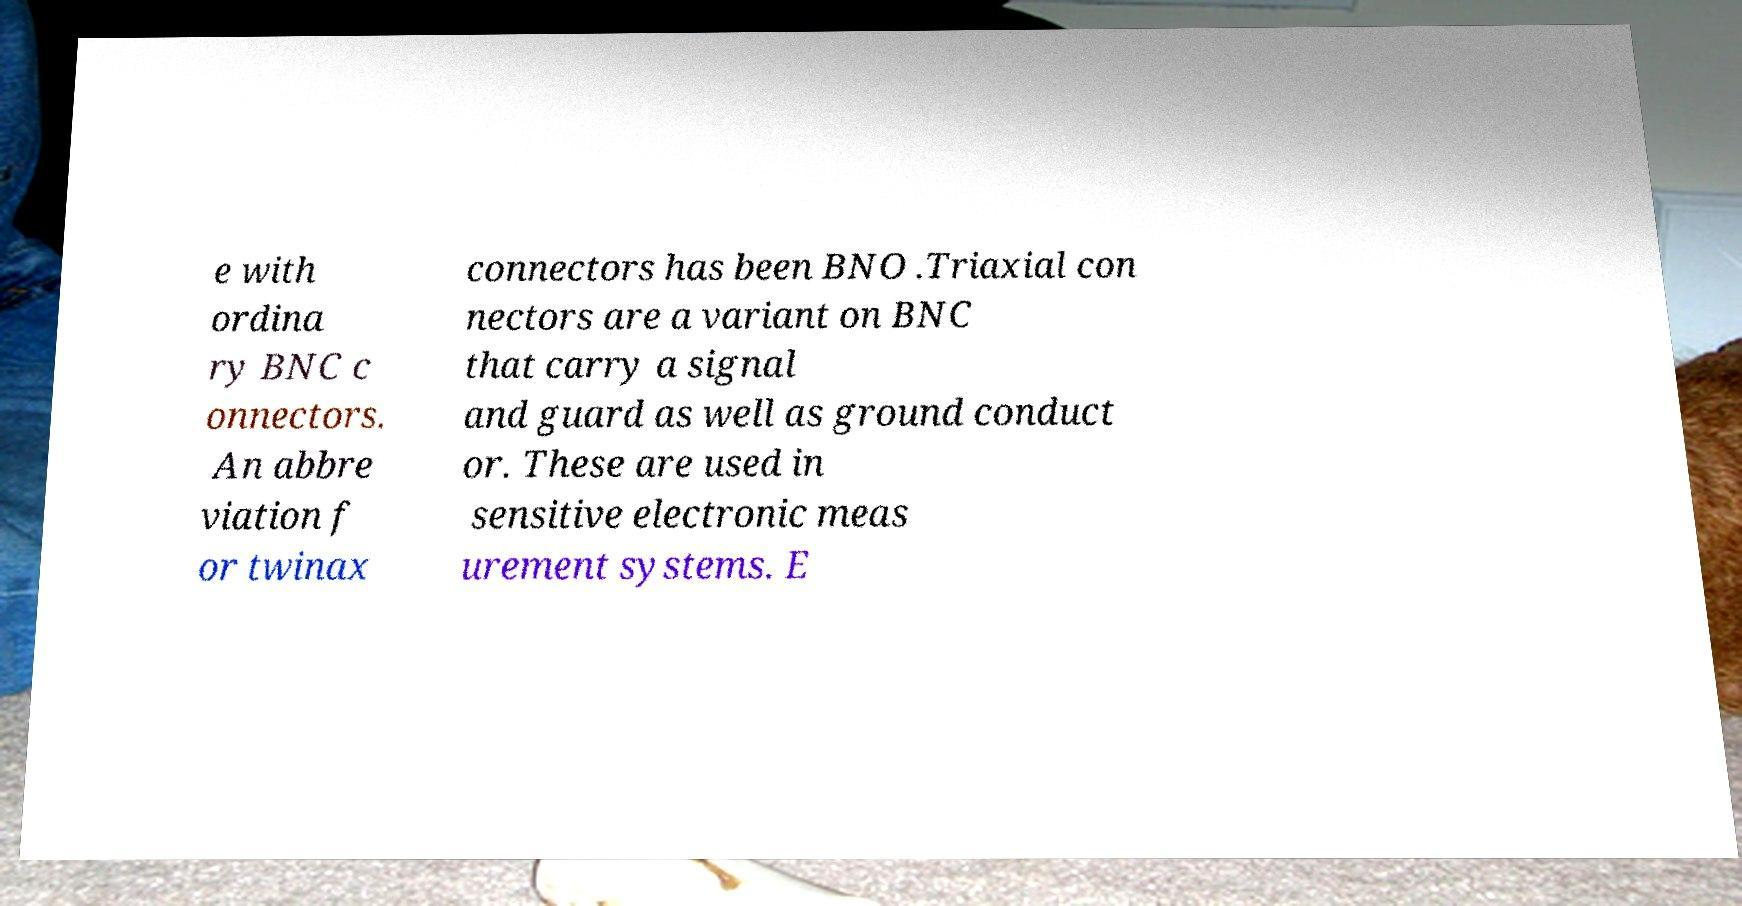Could you assist in decoding the text presented in this image and type it out clearly? e with ordina ry BNC c onnectors. An abbre viation f or twinax connectors has been BNO .Triaxial con nectors are a variant on BNC that carry a signal and guard as well as ground conduct or. These are used in sensitive electronic meas urement systems. E 